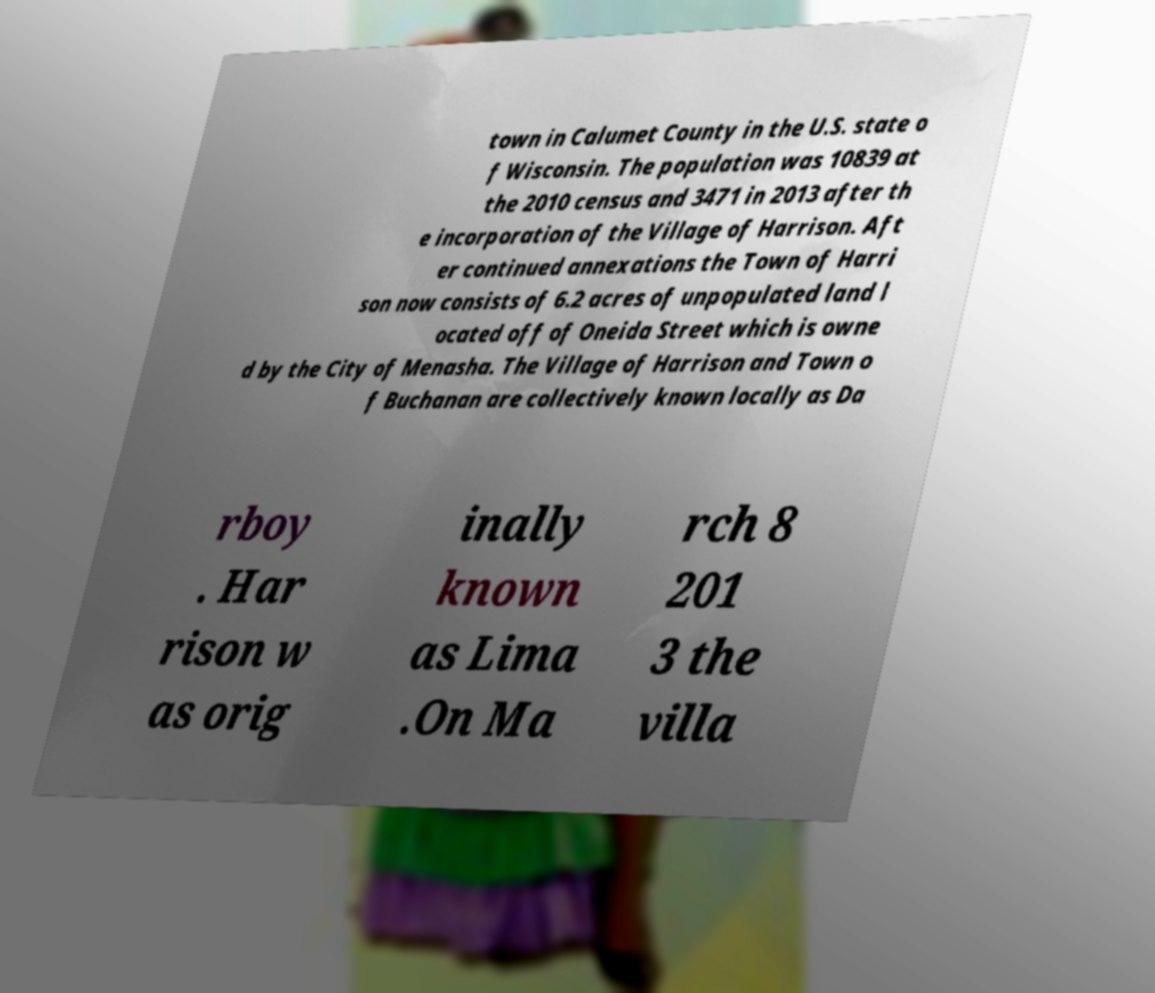Please read and relay the text visible in this image. What does it say? town in Calumet County in the U.S. state o f Wisconsin. The population was 10839 at the 2010 census and 3471 in 2013 after th e incorporation of the Village of Harrison. Aft er continued annexations the Town of Harri son now consists of 6.2 acres of unpopulated land l ocated off of Oneida Street which is owne d by the City of Menasha. The Village of Harrison and Town o f Buchanan are collectively known locally as Da rboy . Har rison w as orig inally known as Lima .On Ma rch 8 201 3 the villa 